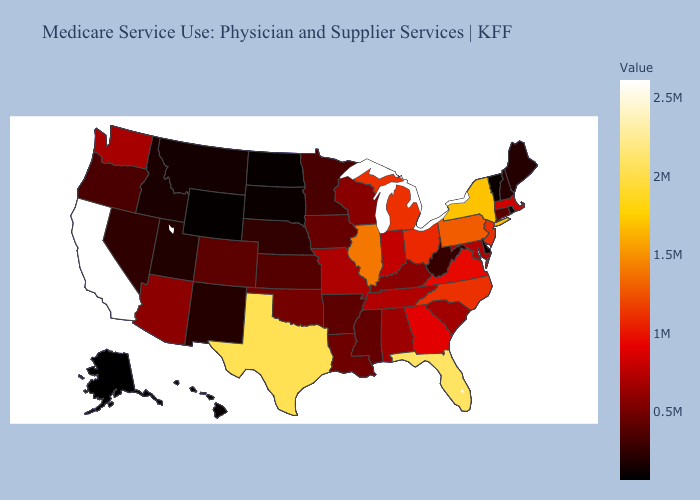Among the states that border Tennessee , does Georgia have the lowest value?
Keep it brief. No. Among the states that border North Carolina , which have the highest value?
Keep it brief. Virginia. Does Alaska have the lowest value in the USA?
Concise answer only. Yes. Which states have the lowest value in the USA?
Write a very short answer. Alaska. Among the states that border Tennessee , which have the lowest value?
Keep it brief. Arkansas. Does Nevada have the highest value in the USA?
Be succinct. No. Does Alaska have the lowest value in the West?
Short answer required. Yes. 